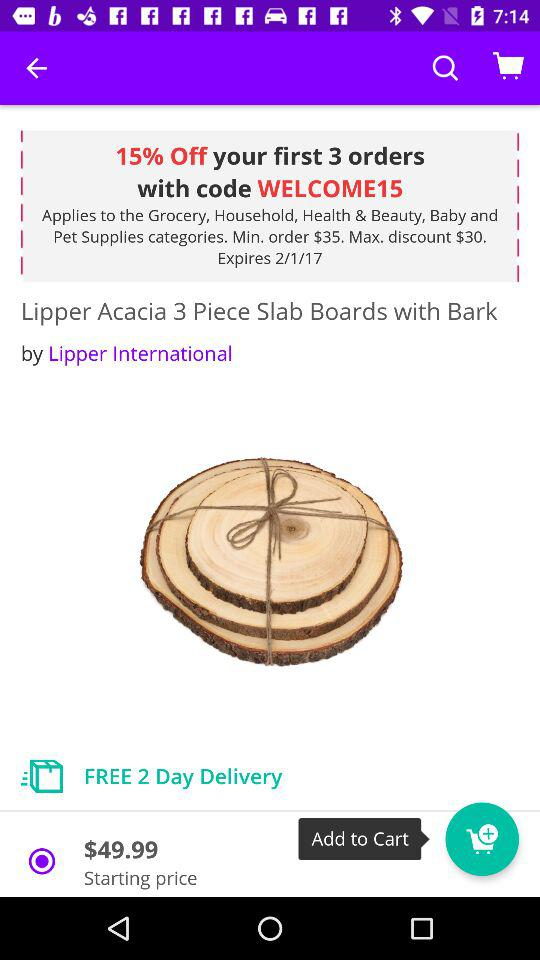What is the minimum order price to get a discount? The minimum order price to get a discount is $35. 